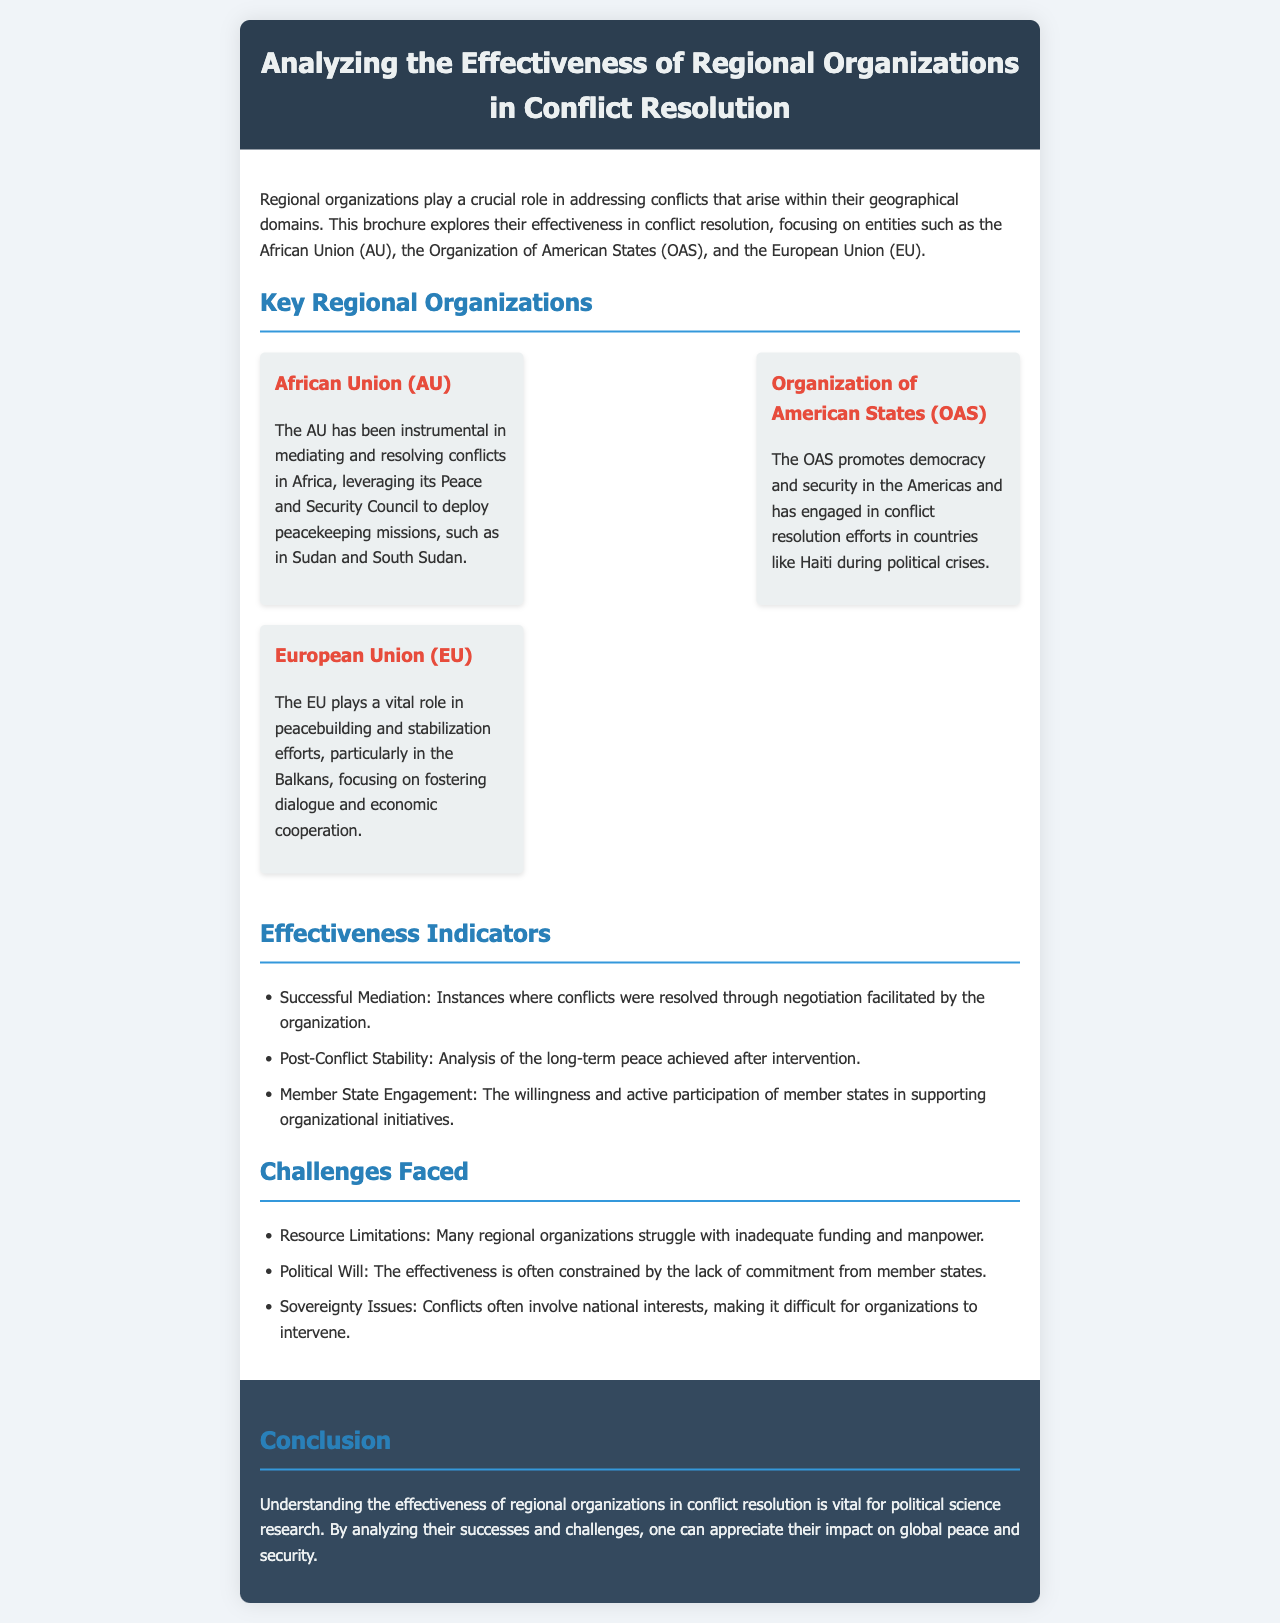What is the title of the brochure? The title of the brochure is stated at the top of the document, summarizing its main theme.
Answer: Analyzing the Effectiveness of Regional Organizations in Conflict Resolution Which regional organization is known for its Peace and Security Council? The document mentions that the African Union utilizes its Peace and Security Council for conflict resolution.
Answer: African Union (AU) In which country did the OAS engage during political crises? The OAS's involvement in resolving conflicts is exemplified by its engagement in Haiti mentioned in the brochure.
Answer: Haiti What is one indicator of effectiveness discussed? The brochure lists indicators for measuring effectiveness, with one being successful mediation.
Answer: Successful Mediation What challenge is associated with limited funding? The document highlights resource limitations as a significant challenge affecting regional organizations' operations.
Answer: Resource Limitations What is a common issue that hampers effective interventions? The text points out that political will is often lacking, which restricts effectiveness in conflict resolution.
Answer: Political Will What role does the EU play in peacebuilding? The EU's role in peacebuilding, as discussed, involves fostering dialogue and economic cooperation, especially in the Balkans.
Answer: Peacebuilding and stabilization efforts in the Balkans How many key regional organizations are mentioned in the brochure? The brochure explicitly mentions three key regional organizations that play a role in conflict resolution.
Answer: Three 